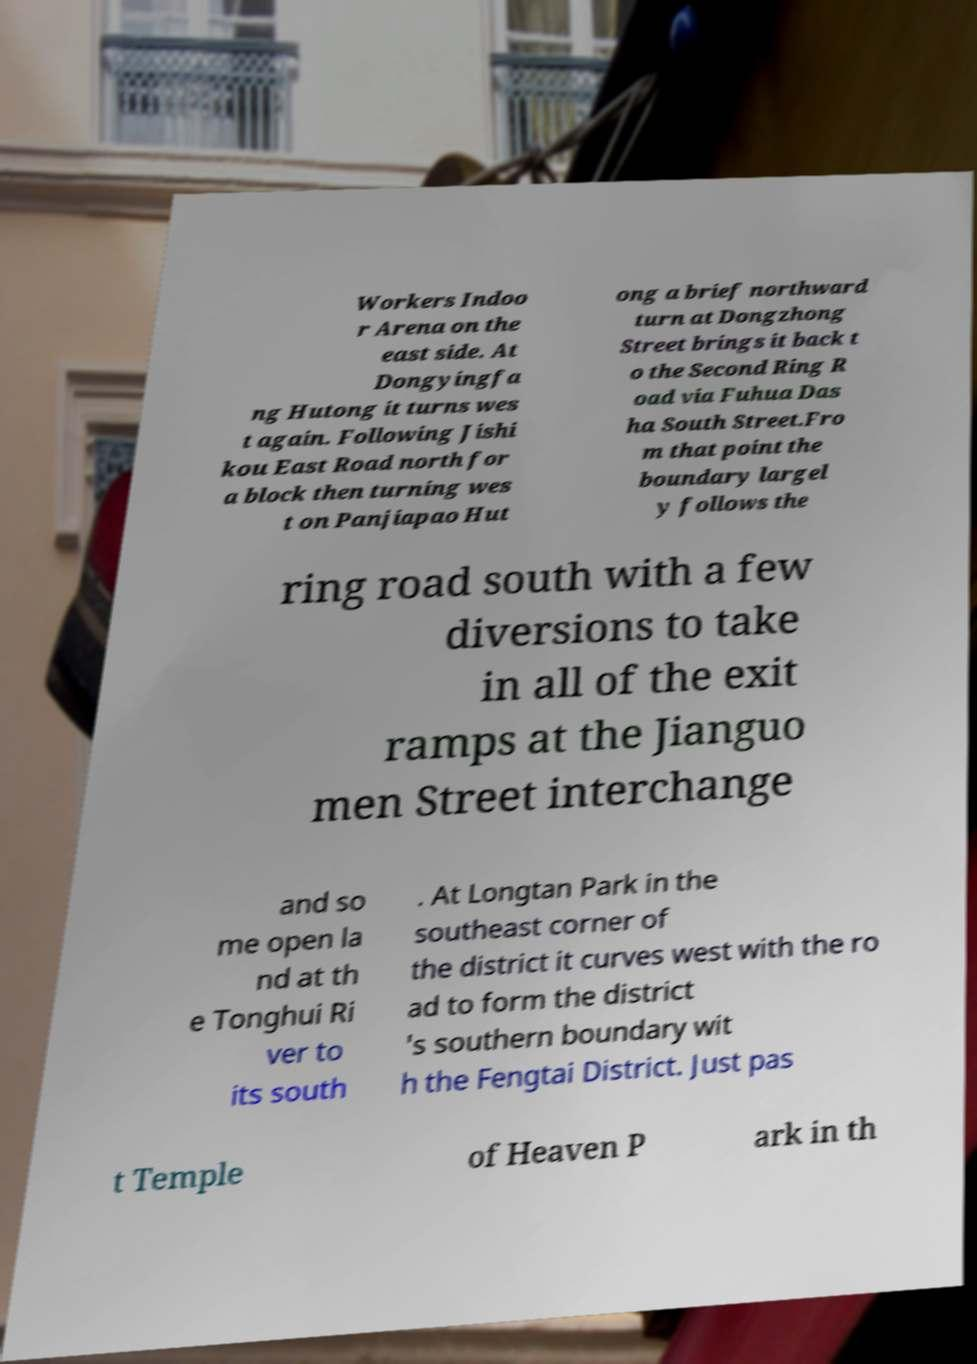I need the written content from this picture converted into text. Can you do that? Workers Indoo r Arena on the east side. At Dongyingfa ng Hutong it turns wes t again. Following Jishi kou East Road north for a block then turning wes t on Panjiapao Hut ong a brief northward turn at Dongzhong Street brings it back t o the Second Ring R oad via Fuhua Das ha South Street.Fro m that point the boundary largel y follows the ring road south with a few diversions to take in all of the exit ramps at the Jianguo men Street interchange and so me open la nd at th e Tonghui Ri ver to its south . At Longtan Park in the southeast corner of the district it curves west with the ro ad to form the district 's southern boundary wit h the Fengtai District. Just pas t Temple of Heaven P ark in th 